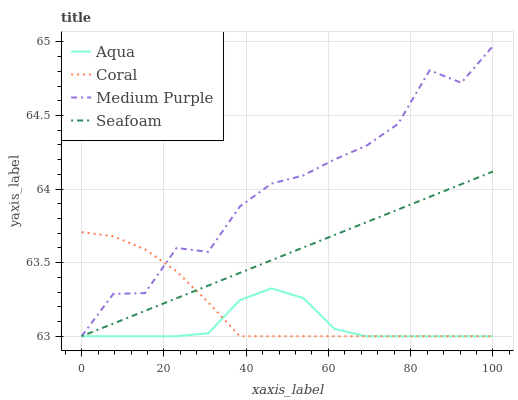Does Aqua have the minimum area under the curve?
Answer yes or no. Yes. Does Medium Purple have the maximum area under the curve?
Answer yes or no. Yes. Does Coral have the minimum area under the curve?
Answer yes or no. No. Does Coral have the maximum area under the curve?
Answer yes or no. No. Is Seafoam the smoothest?
Answer yes or no. Yes. Is Medium Purple the roughest?
Answer yes or no. Yes. Is Coral the smoothest?
Answer yes or no. No. Is Coral the roughest?
Answer yes or no. No. Does Medium Purple have the highest value?
Answer yes or no. Yes. Does Coral have the highest value?
Answer yes or no. No. Does Seafoam intersect Medium Purple?
Answer yes or no. Yes. Is Seafoam less than Medium Purple?
Answer yes or no. No. Is Seafoam greater than Medium Purple?
Answer yes or no. No. 